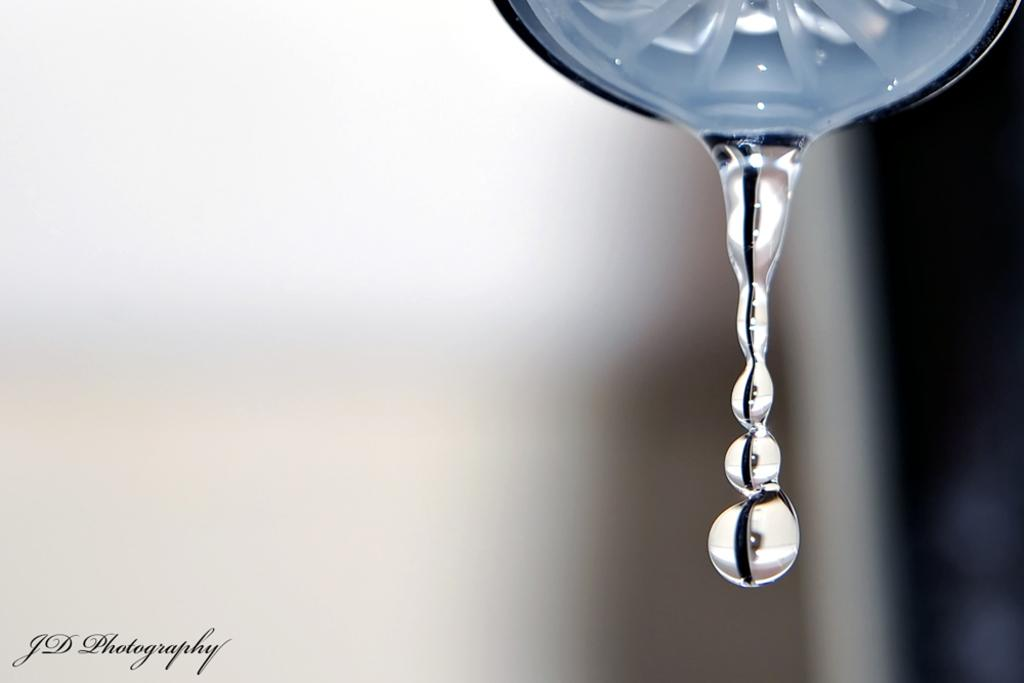What is the source of the water drops in the image? There are water drops coming out from an object at the top of the image. What can be found in the lower left corner of the image? There is a watermark in the left bottom of the image. How would you describe the background of the image? The background of the image is blurry. What feelings of regret can be seen in the image? There are no feelings or emotions depicted in the image, as it is a photograph of water drops and a blurry background. Can you describe the street where the image was taken? There is no street present in the image; it is a close-up shot of water drops and a watermark. 